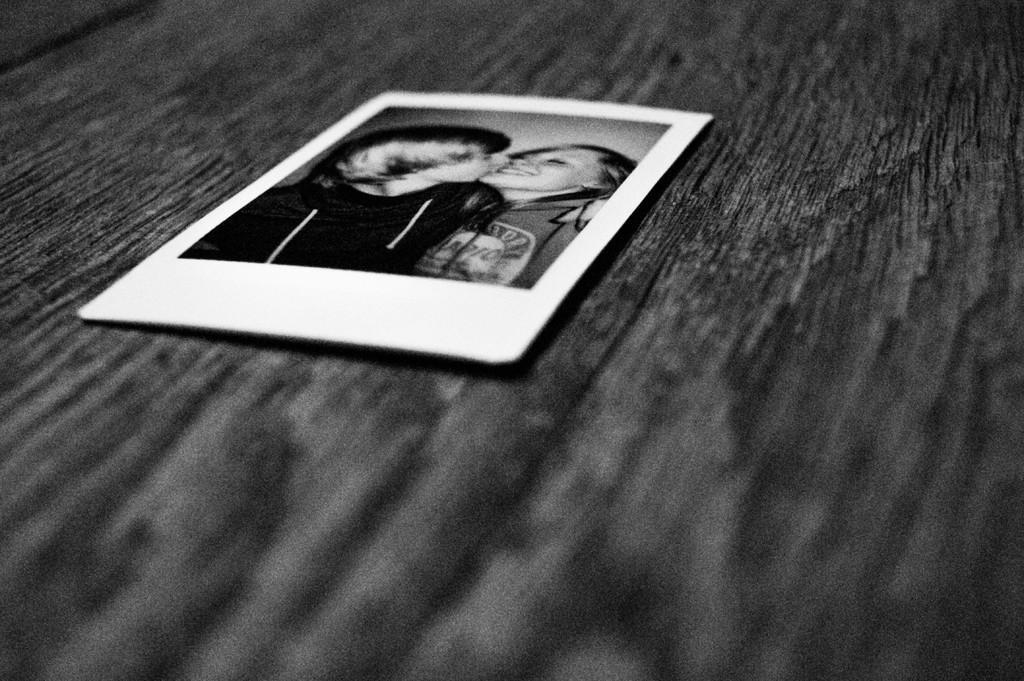Can you describe this image briefly? This is a black and white image. In this image we can see photo placed on the table. 